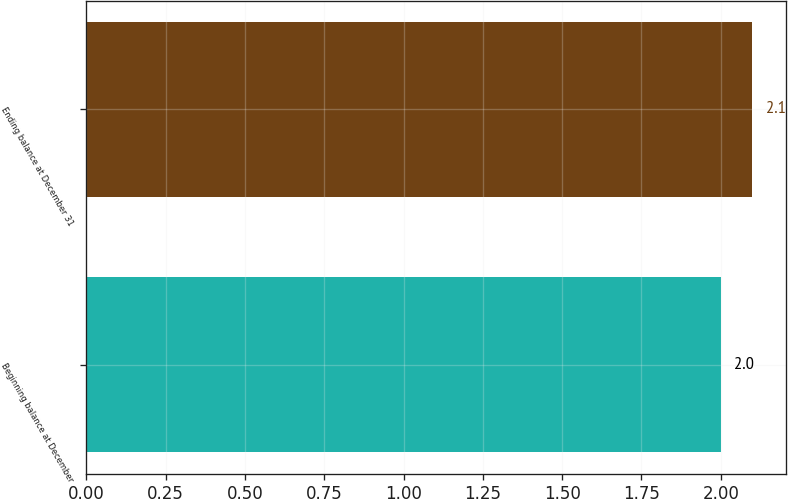<chart> <loc_0><loc_0><loc_500><loc_500><bar_chart><fcel>Beginning balance at December<fcel>Ending balance at December 31<nl><fcel>2<fcel>2.1<nl></chart> 